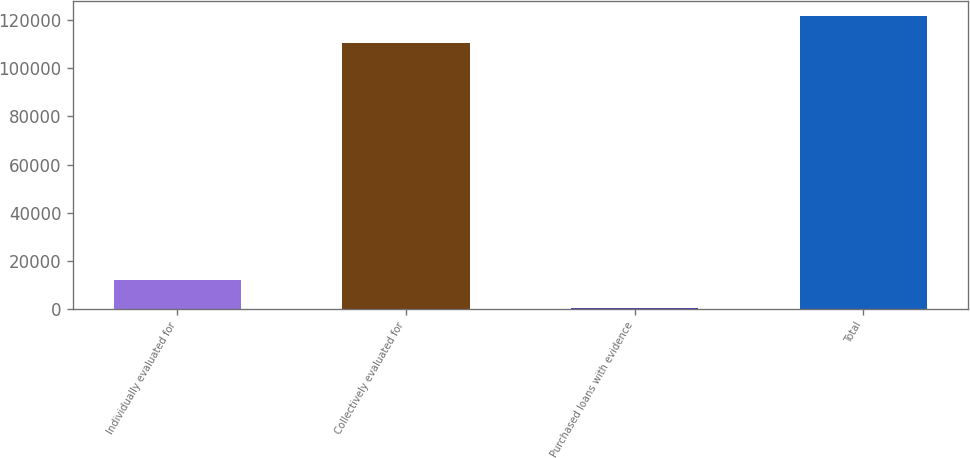Convert chart. <chart><loc_0><loc_0><loc_500><loc_500><bar_chart><fcel>Individually evaluated for<fcel>Collectively evaluated for<fcel>Purchased loans with evidence<fcel>Total<nl><fcel>11778.1<fcel>110417<fcel>421<fcel>121774<nl></chart> 